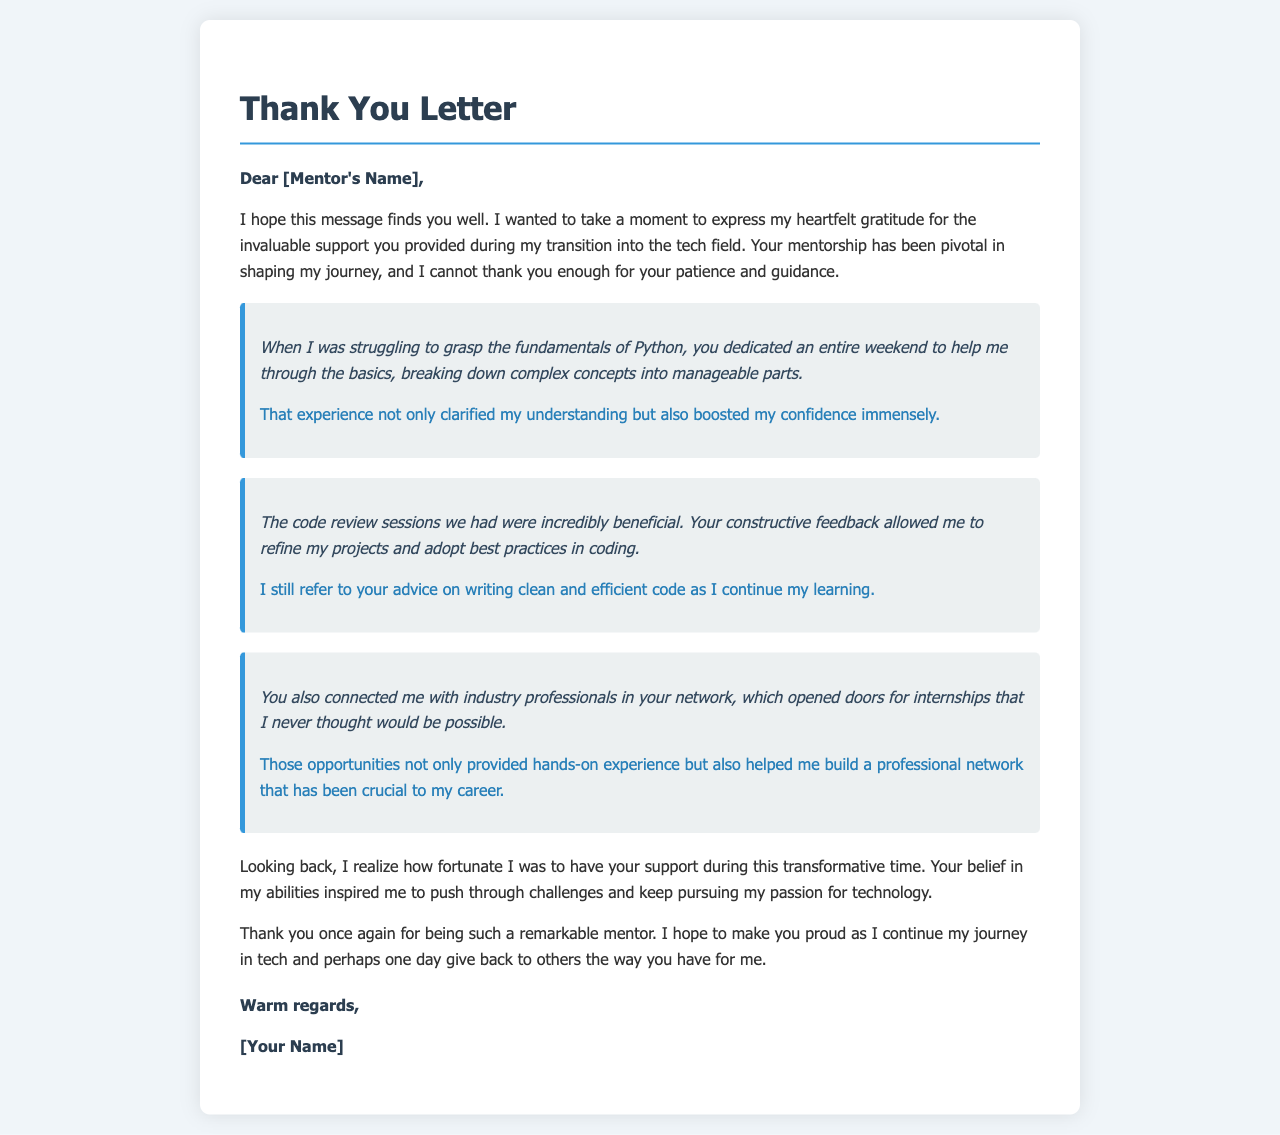What is the name of the recipient? The name of the recipient is indicated in the greeting section of the letter as "[Mentor's Name]."
Answer: [Mentor's Name] What primary subject does the letter address? The primary subject of the letter is to express gratitude for mentorship during a transition into the tech field.
Answer: gratitude How many specific instances of support are highlighted in the letter? The letter highlights three specific instances of support provided by the mentor.
Answer: three What programming language did the mentor help with? The letter specifies that the mentor helped with the fundamentals of Python.
Answer: Python What type of feedback did the mentor provide during code review sessions? The feedback from the mentor was described as constructive, allowing for project refinement and the adoption of best practices.
Answer: constructive What was the impact of the mentor's help on understanding? The mentor's help significantly boosted the mentee's confidence and clarified understanding.
Answer: boosted confidence What professional opportunities did the mentor provide? The mentor connected the mentee with industry professionals for internships.
Answer: internships What closing phrase is used in the letter? The closing phrase used in the letter is "Warm regards."
Answer: Warm regards Who is the sign-off attributed to? The sign-off is attributed to "[Your Name]."
Answer: [Your Name] 